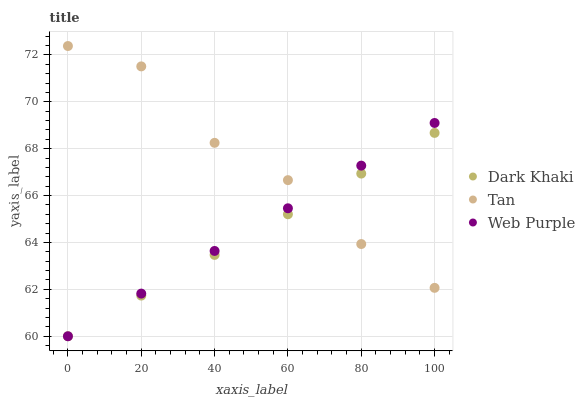Does Dark Khaki have the minimum area under the curve?
Answer yes or no. Yes. Does Tan have the maximum area under the curve?
Answer yes or no. Yes. Does Web Purple have the minimum area under the curve?
Answer yes or no. No. Does Web Purple have the maximum area under the curve?
Answer yes or no. No. Is Dark Khaki the smoothest?
Answer yes or no. Yes. Is Tan the roughest?
Answer yes or no. Yes. Is Tan the smoothest?
Answer yes or no. No. Is Web Purple the roughest?
Answer yes or no. No. Does Dark Khaki have the lowest value?
Answer yes or no. Yes. Does Tan have the lowest value?
Answer yes or no. No. Does Tan have the highest value?
Answer yes or no. Yes. Does Web Purple have the highest value?
Answer yes or no. No. Does Tan intersect Dark Khaki?
Answer yes or no. Yes. Is Tan less than Dark Khaki?
Answer yes or no. No. Is Tan greater than Dark Khaki?
Answer yes or no. No. 